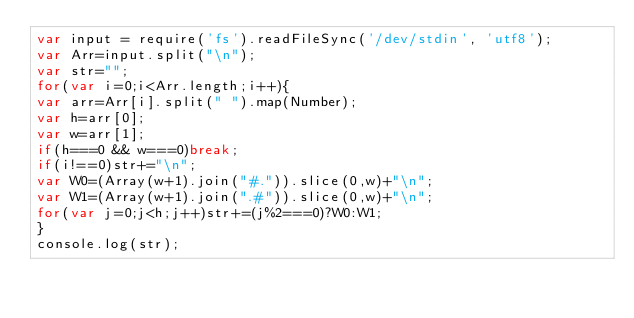<code> <loc_0><loc_0><loc_500><loc_500><_JavaScript_>var input = require('fs').readFileSync('/dev/stdin', 'utf8');
var Arr=input.split("\n");
var str="";
for(var i=0;i<Arr.length;i++){
var arr=Arr[i].split(" ").map(Number);
var h=arr[0];
var w=arr[1];
if(h===0 && w===0)break;
if(i!==0)str+="\n";
var W0=(Array(w+1).join("#.")).slice(0,w)+"\n";
var W1=(Array(w+1).join(".#")).slice(0,w)+"\n";
for(var j=0;j<h;j++)str+=(j%2===0)?W0:W1;
}
console.log(str);</code> 